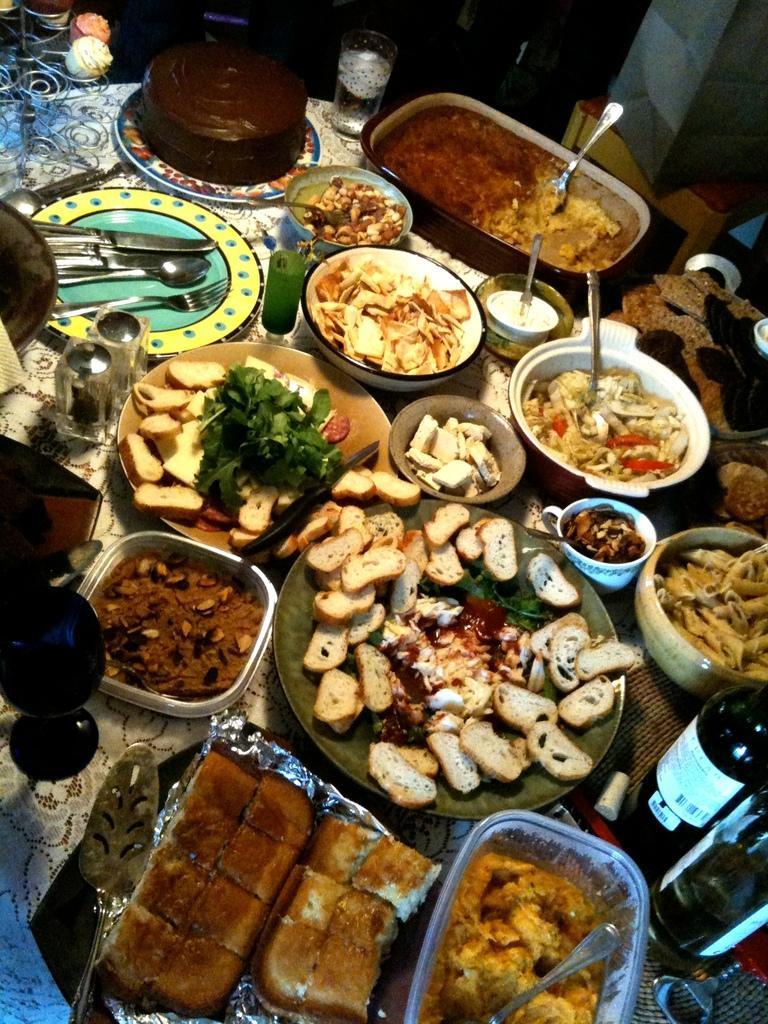How would you summarize this image in a sentence or two? There are food items, bottles and spoons in the foreground area of the image. 